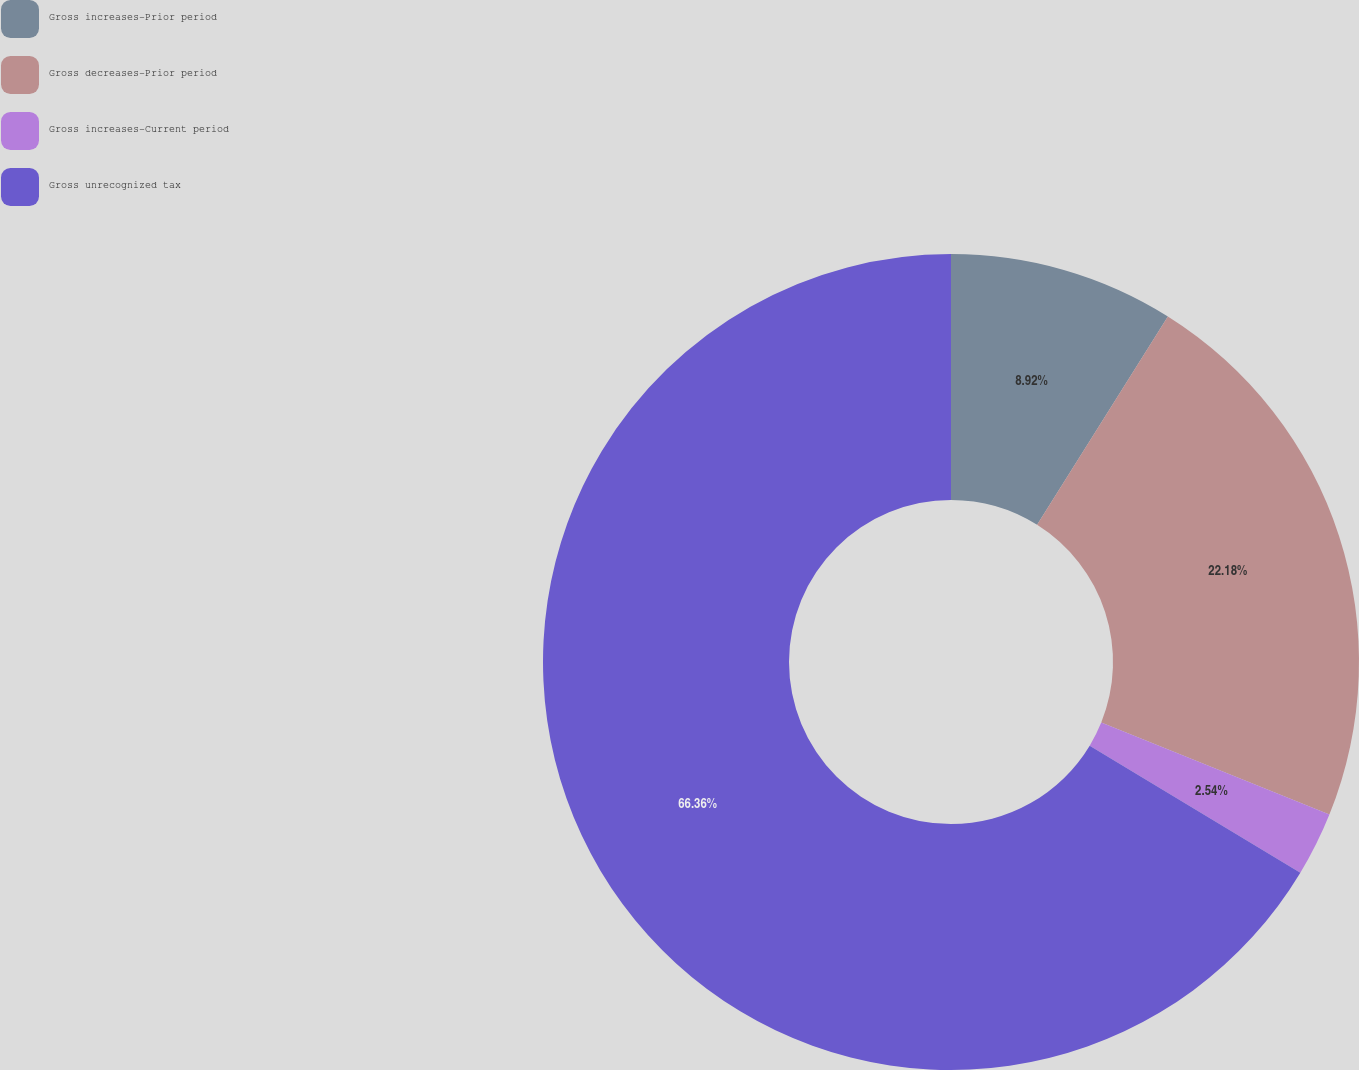Convert chart. <chart><loc_0><loc_0><loc_500><loc_500><pie_chart><fcel>Gross increases-Prior period<fcel>Gross decreases-Prior period<fcel>Gross increases-Current period<fcel>Gross unrecognized tax<nl><fcel>8.92%<fcel>22.18%<fcel>2.54%<fcel>66.36%<nl></chart> 